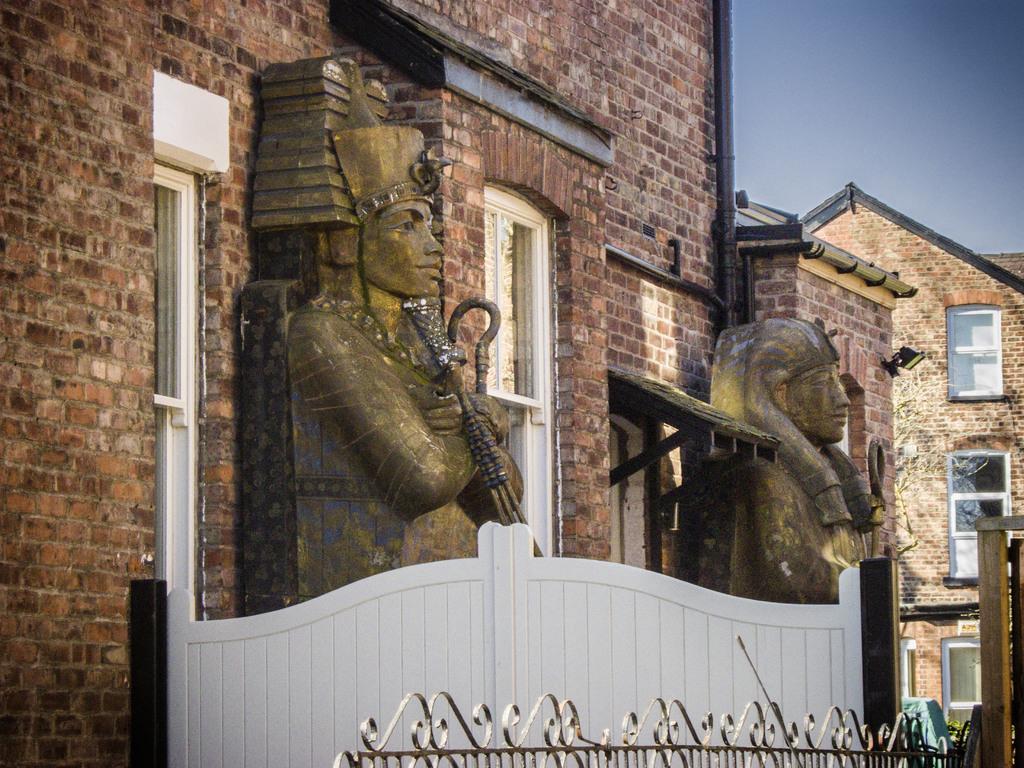Can you describe this image briefly? This image consists of buildings. There are statues on buildings. There is sky at the top. 